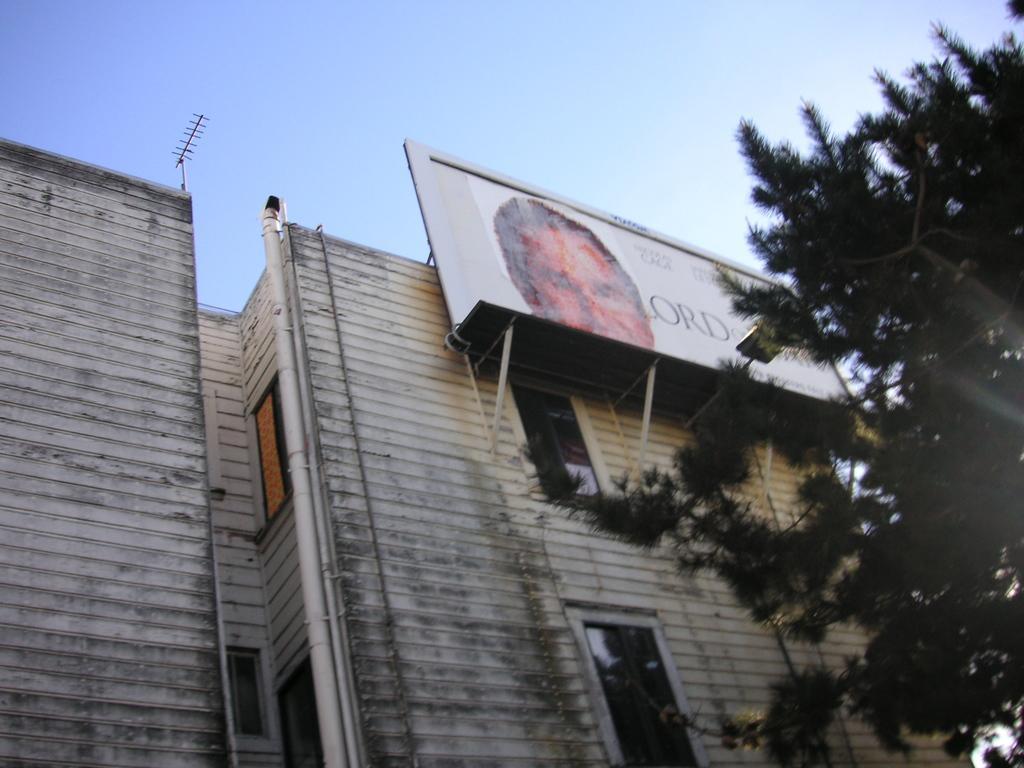Could you give a brief overview of what you see in this image? In this image in the center there is a building, and on the right side there is a tree and there is one board on the building and antenna. At the top there is sky. 